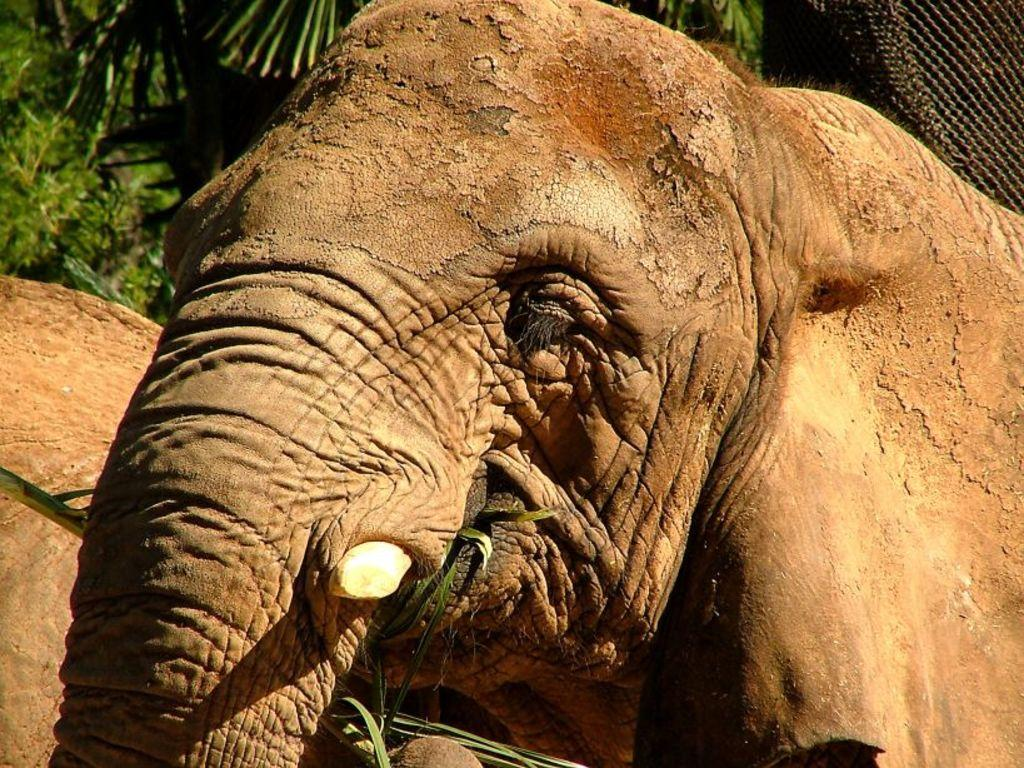What is the main subject in the foreground of the image? There is an elephant in the foreground of the image. What is the elephant doing in the image? The elephant is eating leaves. Can you see any other elephants in the image? Yes, there appears to be another elephant in the background of the image. What type of vegetation is visible in the image? Trees are visible at the top of the image. What type of square object can be seen in the image? There is no square object present in the image. Can you describe the fog in the image? There is no fog present in the image. 